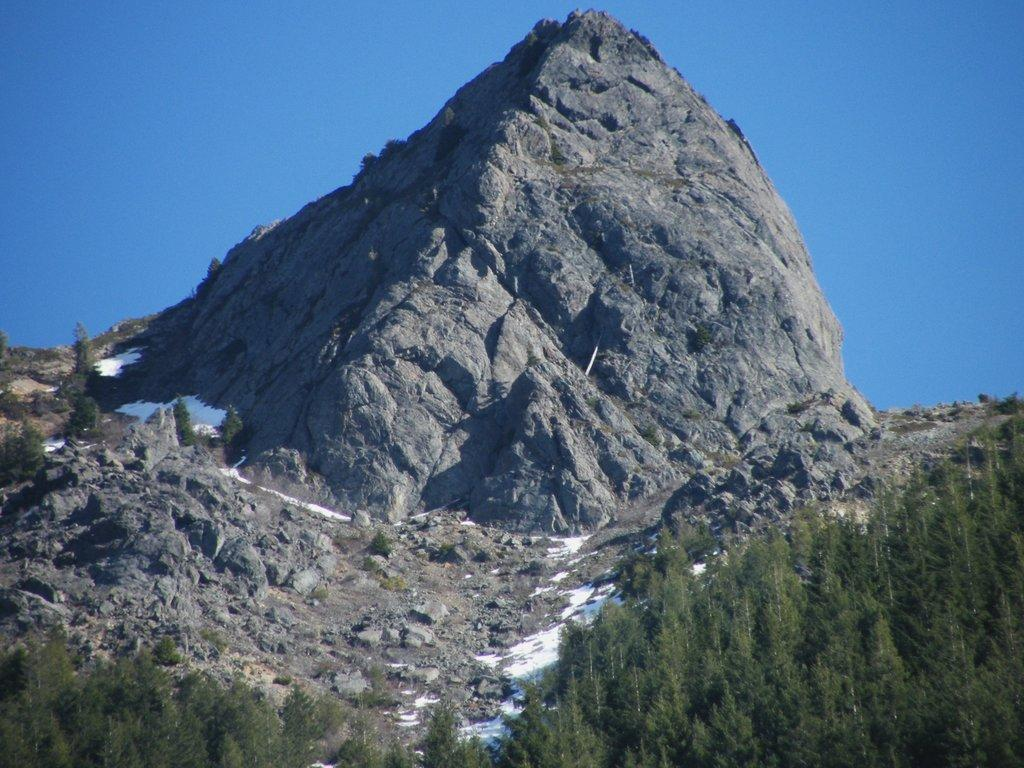What type of vegetation is at the bottom of the image? There are trees at the bottom of the image. What geographical feature is in the center of the image? There are mountains in the center of the image. What type of terrain is present in the image? There are rocks and sand in the image. What is visible at the top of the image? The sky is visible at the top of the image. What type of government is depicted in the image? There is no government depicted in the image; it features natural landscapes such as trees, mountains, rocks, sand, and sky. Can you tell me how many governors are present in the image? There are present in the image? 